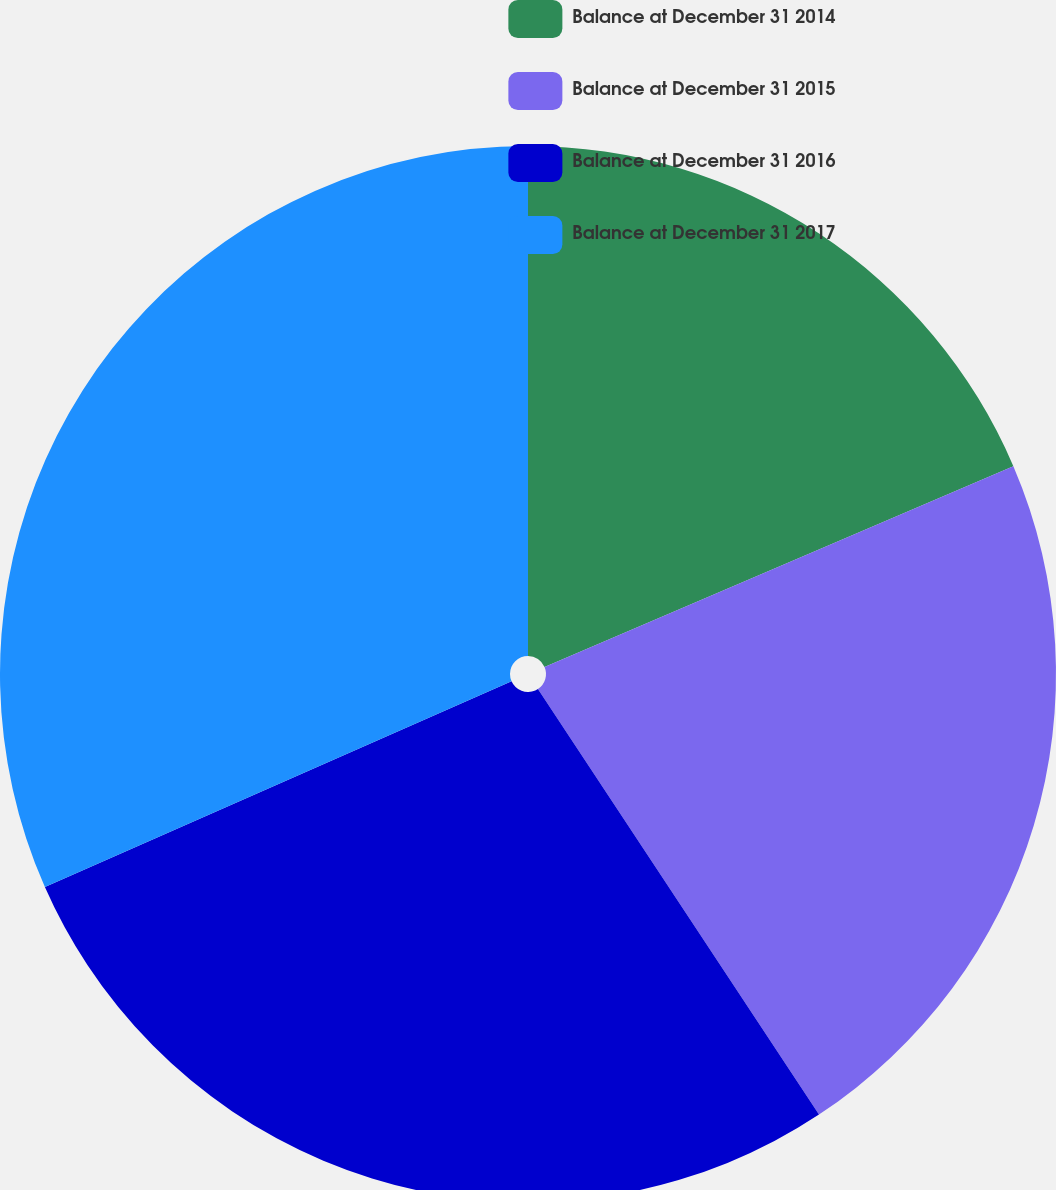Convert chart. <chart><loc_0><loc_0><loc_500><loc_500><pie_chart><fcel>Balance at December 31 2014<fcel>Balance at December 31 2015<fcel>Balance at December 31 2016<fcel>Balance at December 31 2017<nl><fcel>18.56%<fcel>22.15%<fcel>27.68%<fcel>31.61%<nl></chart> 